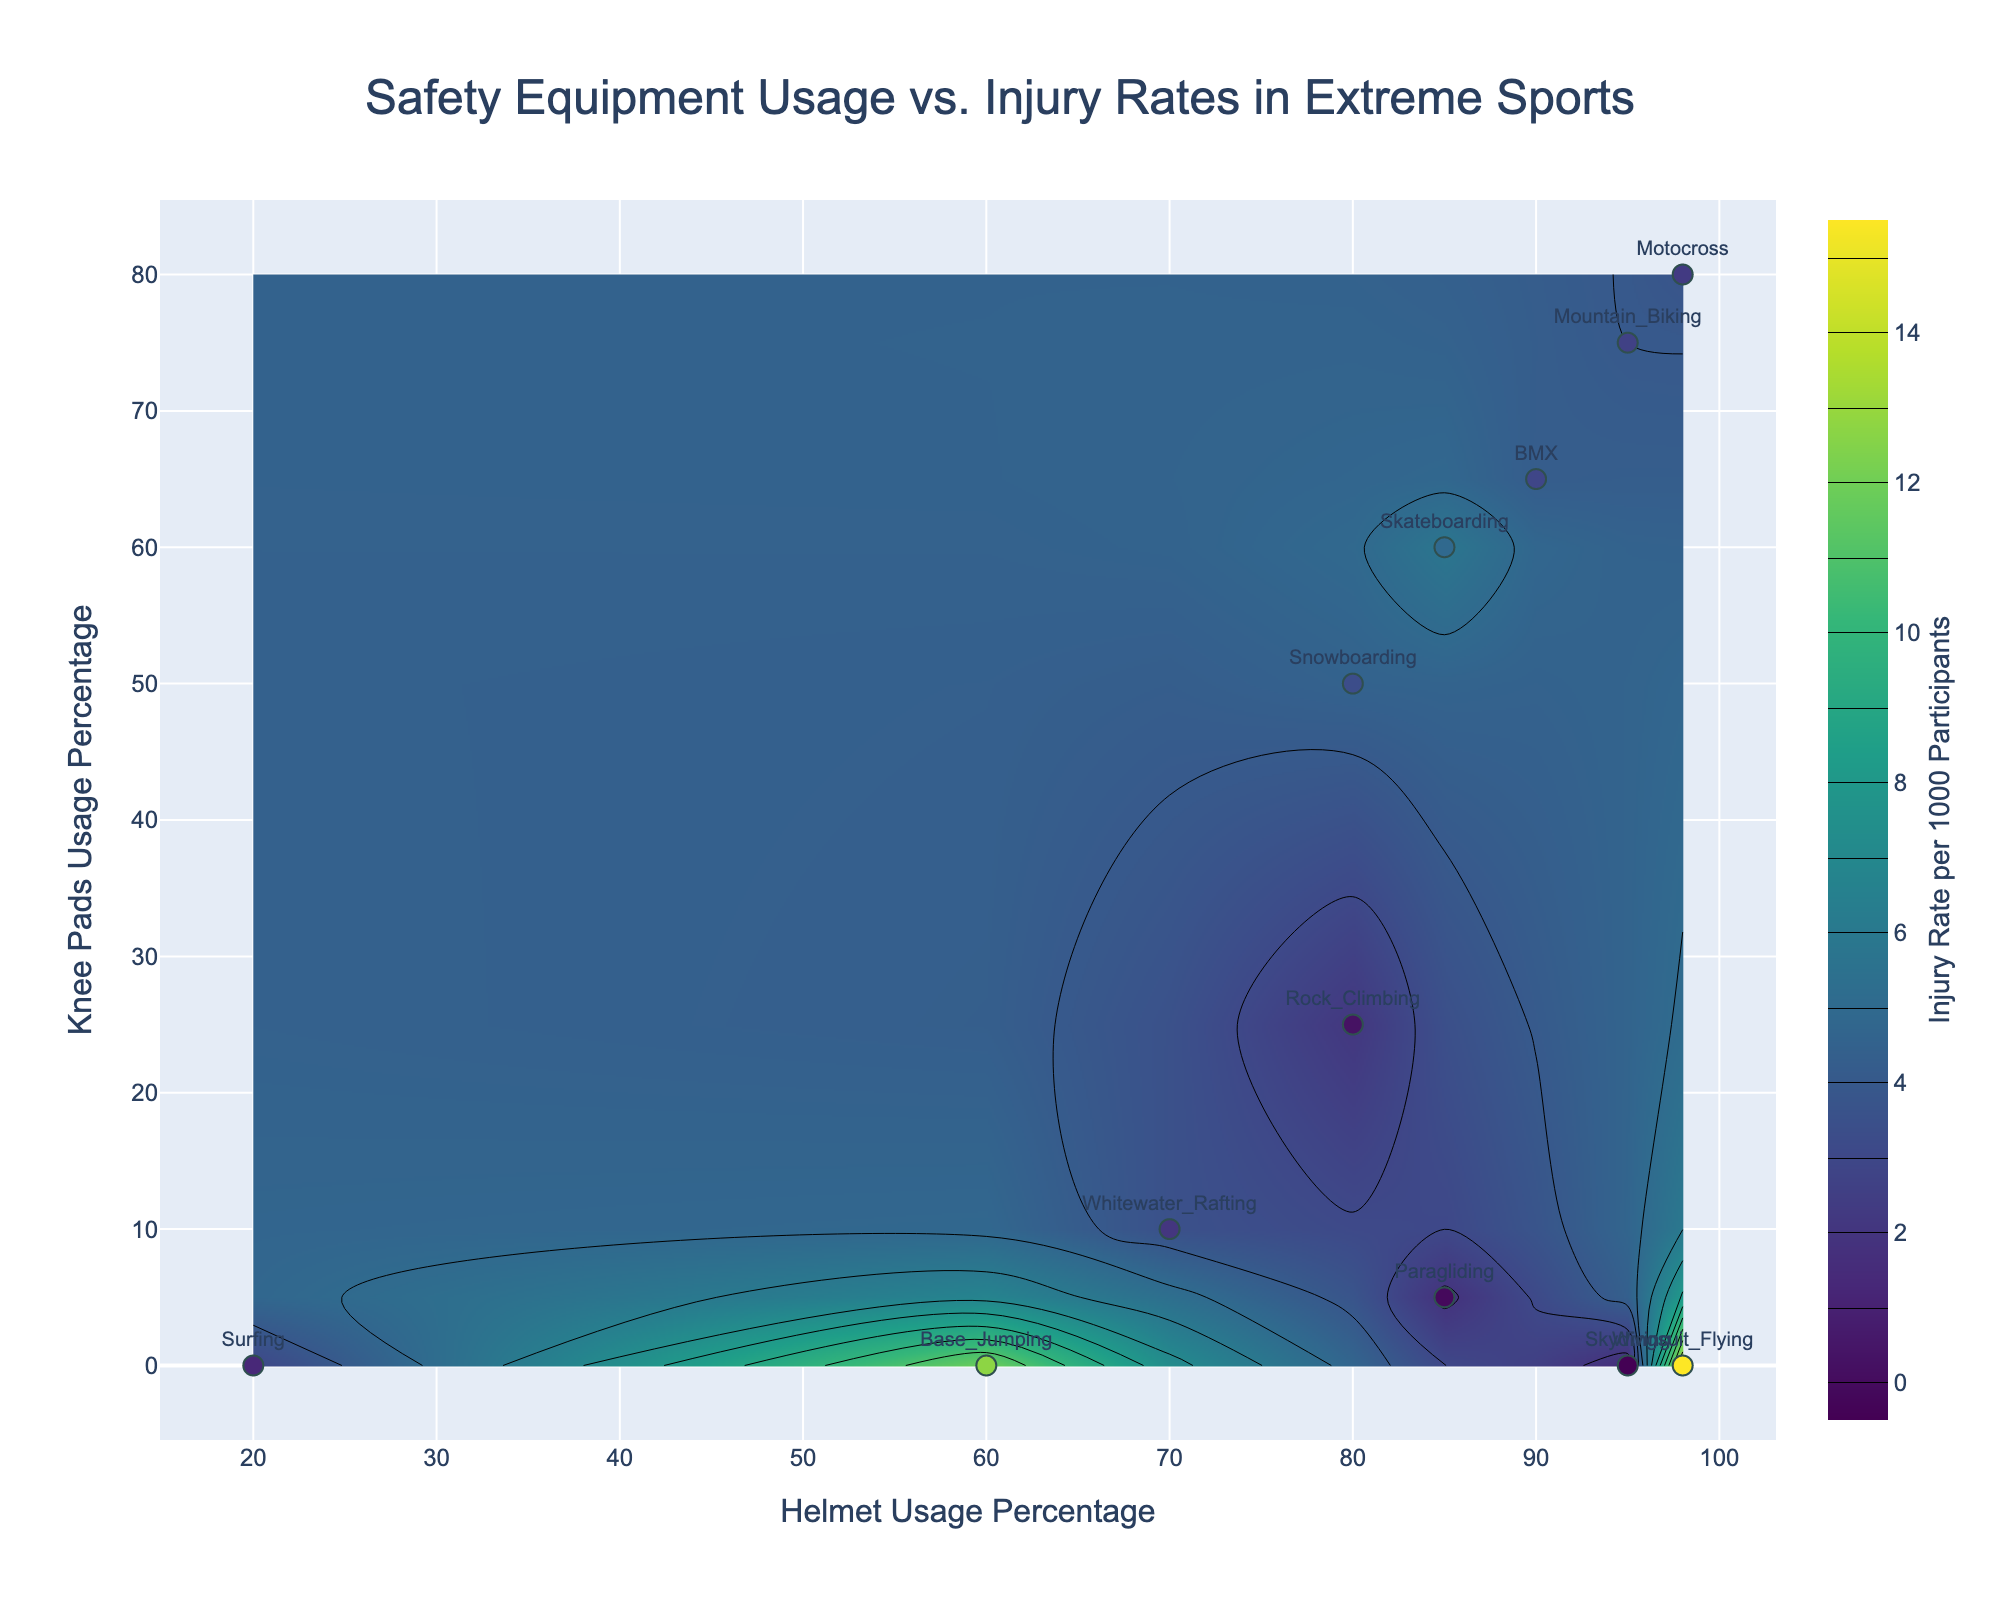What is the title of the plot? The title of the plot is placed at the top of the figure and typically provides the viewer with an overview of what the data represents. In this case, the title can be easily read directly from the figure.
Answer: Safety Equipment Usage vs. Injury Rates in Extreme Sports What is represented by the x-axis? The x-axis in the figure represents one of the variables being plotted. By reading the label, we can understand what is measured along this axis.
Answer: Helmet Usage Percentage How many extreme sports are represented in the plot? Each data point in the scatter plot represents a distinct extreme sport. By counting the number of markers or labels, we can determine the total number of sports depicted.
Answer: Twelve Which extreme sport has the highest injury rate? To determine this, we look for the data point with the highest value on the color scale or one of the labeled markers. By checking the corresponding sport name, we can identify the sport with the highest rate.
Answer: Wingsuit Flying Is there a general trend between helmet usage percentage and injury rates? To answer this, we analyze the contour lines and the overall distribution of the data points. We look for any visible pattern that shows a relationship between helmet usage and injury rates.
Answer: Higher helmet usage does not necessarily correlate with lower injury rates Which sport has a higher injury rate, Skateboarding or Mountain Biking? By finding the positions of both Skateboarding and Mountain Biking on the plot and comparing the z-values (height/color), we can identify which has the higher rate.
Answer: Skateboarding In which range of helmet usage percentage do most sports fall? By observing the x-axis values of most of the data points, we can identify the range where the majority lie.
Answer: 80% to 98% What is the injury rate for Motocross? The injury rate for Motocross can be found by locating it on the plot and reading the corresponding value from the contours or colorbar.
Answer: 3.7 per 1000 participants Which sport shows the lowest knee pads usage? To answer this, we need to look at the y-axis and identify the sports at the bottom of the scale.
Answer: Skydiving, Surfing, Base Jumping, and Wingsuit Flying Do sports with higher knee pads usage generally have lower injury rates? By comparing the y-axis positions (knee pads usage) with the contour values (injury rates), we can check if sports with higher knee pads usage tend to cluster around lower injury rates.
Answer: No, there is no clear trend 